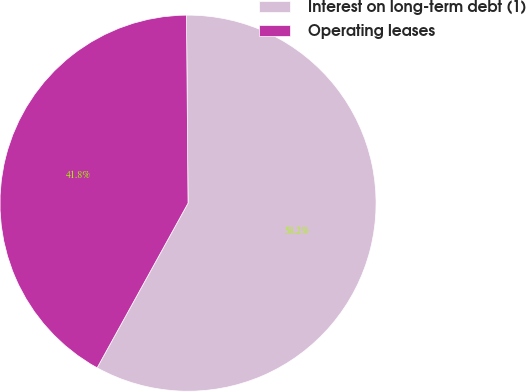Convert chart to OTSL. <chart><loc_0><loc_0><loc_500><loc_500><pie_chart><fcel>Interest on long-term debt (1)<fcel>Operating leases<nl><fcel>58.16%<fcel>41.84%<nl></chart> 